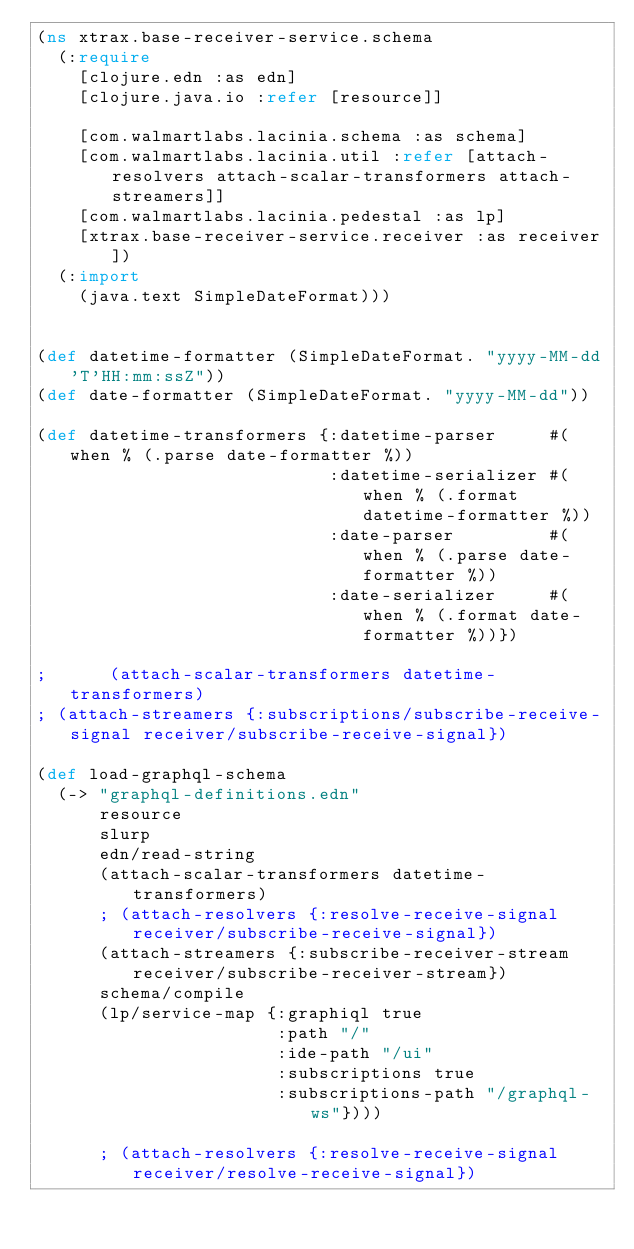Convert code to text. <code><loc_0><loc_0><loc_500><loc_500><_Clojure_>(ns xtrax.base-receiver-service.schema
  (:require
    [clojure.edn :as edn]
    [clojure.java.io :refer [resource]]

    [com.walmartlabs.lacinia.schema :as schema]
    [com.walmartlabs.lacinia.util :refer [attach-resolvers attach-scalar-transformers attach-streamers]]
    [com.walmartlabs.lacinia.pedestal :as lp]
    [xtrax.base-receiver-service.receiver :as receiver])
  (:import
    (java.text SimpleDateFormat)))


(def datetime-formatter (SimpleDateFormat. "yyyy-MM-dd'T'HH:mm:ssZ"))
(def date-formatter (SimpleDateFormat. "yyyy-MM-dd"))

(def datetime-transformers {:datetime-parser     #(when % (.parse date-formatter %))
                            :datetime-serializer #(when % (.format datetime-formatter %))
                            :date-parser         #(when % (.parse date-formatter %))
                            :date-serializer     #(when % (.format date-formatter %))})

;      (attach-scalar-transformers datetime-transformers)
; (attach-streamers {:subscriptions/subscribe-receive-signal receiver/subscribe-receive-signal})

(def load-graphql-schema
  (-> "graphql-definitions.edn"
      resource
      slurp
      edn/read-string
      (attach-scalar-transformers datetime-transformers)
      ; (attach-resolvers {:resolve-receive-signal receiver/subscribe-receive-signal})
      (attach-streamers {:subscribe-receiver-stream receiver/subscribe-receiver-stream})
      schema/compile
      (lp/service-map {:graphiql true
                       :path "/"
                       :ide-path "/ui"
                       :subscriptions true
                       :subscriptions-path "/graphql-ws"})))

      ; (attach-resolvers {:resolve-receive-signal receiver/resolve-receive-signal})
</code> 